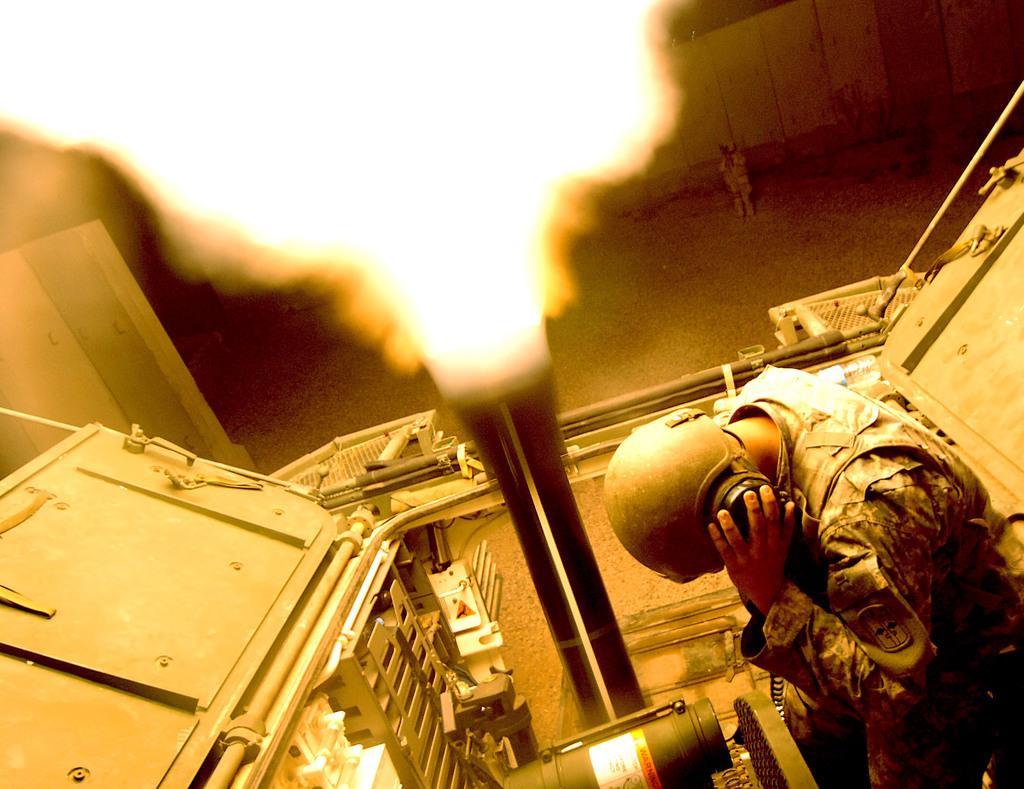How would you summarize this image in a sentence or two? In the picture we can see we can see a man standing with a uniform and helmet with headsets and holding it tightly to the ears and near him we can see an engine with a pipe and smoke and fire from it and behind it we can see a path and a person standing near the wall. 